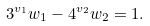Convert formula to latex. <formula><loc_0><loc_0><loc_500><loc_500>3 ^ { v _ { 1 } } w _ { 1 } - 4 ^ { v _ { 2 } } w _ { 2 } = 1 .</formula> 